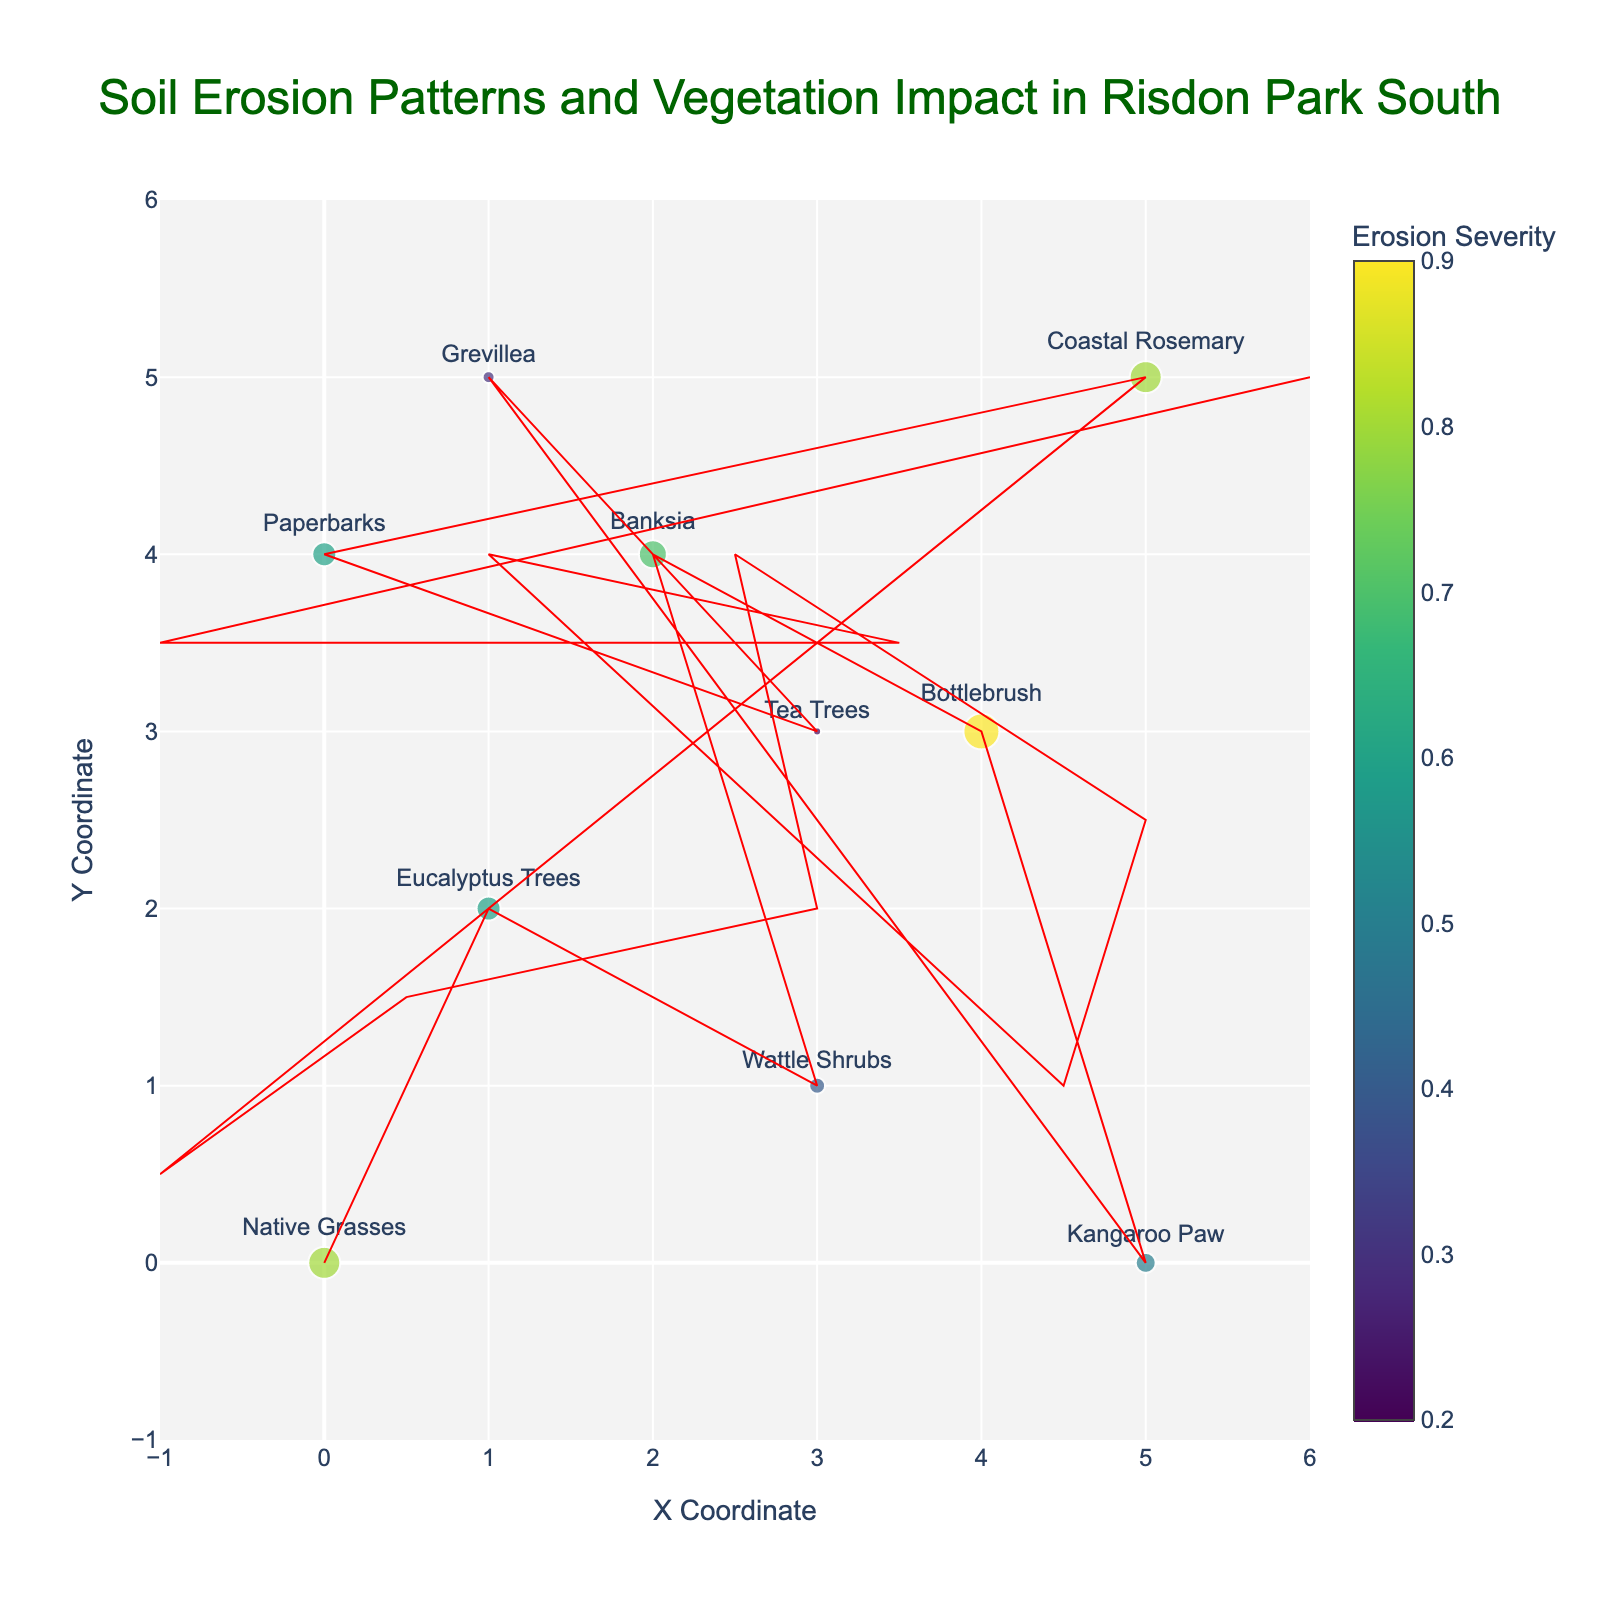What's the title of the plot? The title is located at the top of the plot, usually in larger and bold font. It is "Soil Erosion Patterns and Vegetation Impact in Risdon Park South".
Answer: Soil Erosion Patterns and Vegetation Impact in Risdon Park South How many vegetation types are shown in the plot? By counting each distinct label next to the markers representing different vegetation types, we find ten different vegetation types.
Answer: Ten Which vegetation type is located at the coordinates (4, 3)? The plot shows a marker with a text label at (4, 3). The label indicates this marker represents Bottlebrush.
Answer: Bottlebrush Which point has the highest erosion severity? By examining the color and size of the markers (larger and more intensely colored markers represent higher erosion severity), we find the largest marker at (4, 3) for Bottlebrush.
Answer: Bottlebrush What direction is the soil erosion vector at (0,0) pointing? Analyzing the plot, the arrow at (0, 0) points leftward (-2) and slightly upward (1) from the origin.
Answer: Left and up Which vegetation type experiences upwards soil movement? By observing the direction of arrows, we see that the arrows at coordinates (3, 1) for Wattle Shrubs and (5, 0) for Kangaroo Paw point upward.
Answer: Wattle Shrubs and Kangaroo Paw What is the erosion severity for the Banksia located at (2, 4)? The hovertext or color/intensity of the marker at (2, 4) indicates the erosion severity, which for Banksia is 0.7.
Answer: 0.7 Which vegetation type has the smallest soil erosion severity, and what is its value? Observing the color bar and comparing the markers, the smallest erosion severity is 0.2 observed for Tea Trees at (3, 3).
Answer: Tea Trees, 0.2 How many vegetation types have soil erosion severity above 0.6? By identifying and counting larger, more intensely colored markers that represent erosion severity above 0.6, we find there are four such markers: Native Grasses, Banksia, Bottlebrush, and Coastal Rosemary.
Answer: Four What is the average soil erosion severity across all vegetation types? Summing up all erosion severity values and dividing by the count of vegetation types (which is 10), we get: (0.8 + 0.6 + 0.4 + 0.7 + 0.9 + 0.5 + 0.3 + 0.2 + 0.6 + 0.8) / 10 = 5.8 / 10 = 0.58.
Answer: 0.58 